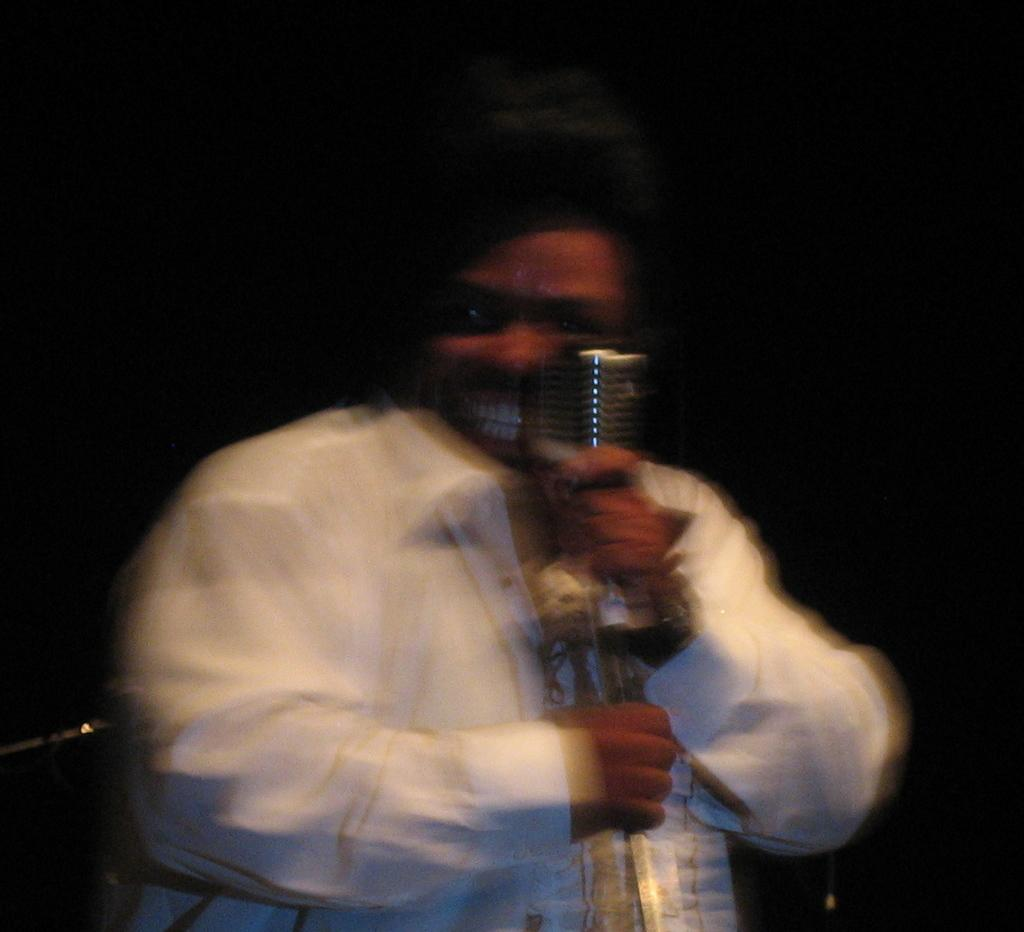Who is the main subject in the image? There is a man in the center of the image. What is the man holding in his hands? The man is holding a microphone in his hands. How many chickens are visible in the image? There are no chickens present in the image. What type of string is being used to control the wind in the image? There is no string or wind present in the image; it features a man holding a microphone. 